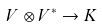<formula> <loc_0><loc_0><loc_500><loc_500>V \otimes V ^ { * } \to K</formula> 